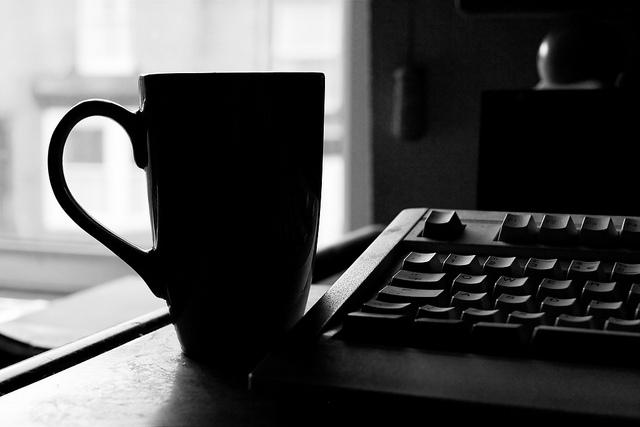Where is the mug?
Answer briefly. Desk. What brand keyboard is featured?
Write a very short answer. Dell. Would these keys be legible in the dark?
Give a very brief answer. No. By itself, the handle on the cup looks like half of a what?
Keep it brief. Heart. What is next to the mug?
Concise answer only. Keyboard. 